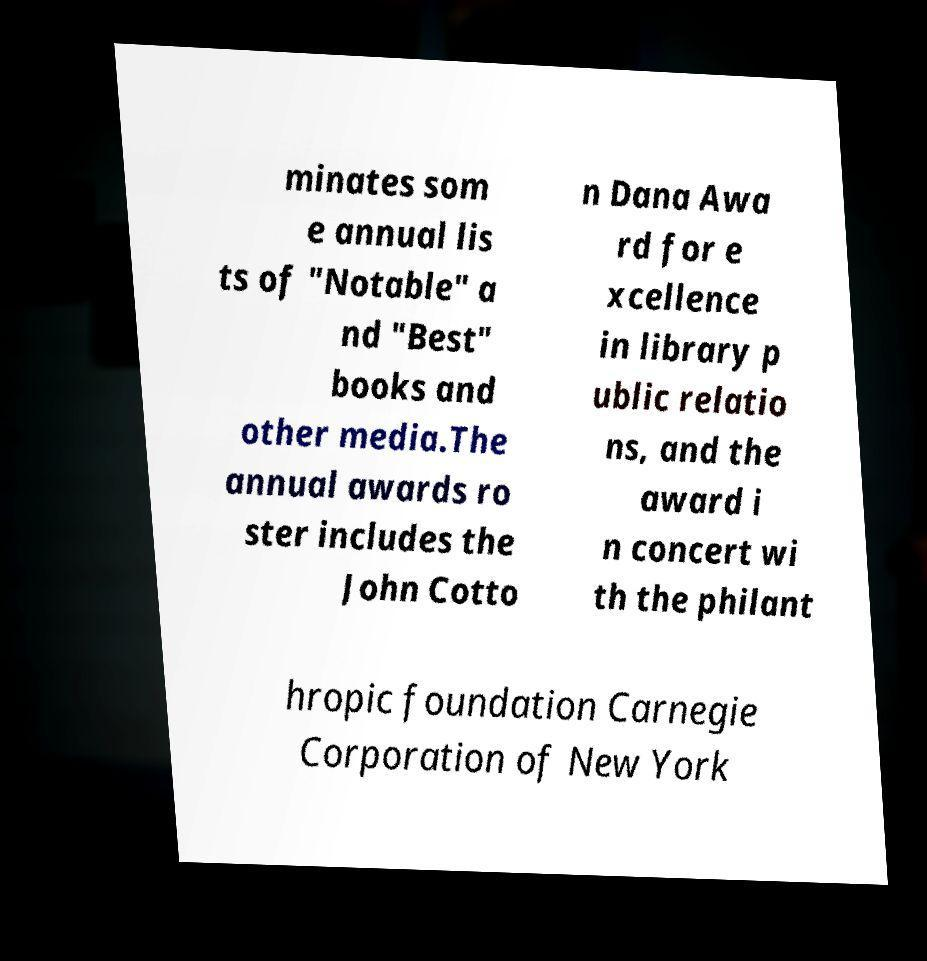Please identify and transcribe the text found in this image. minates som e annual lis ts of "Notable" a nd "Best" books and other media.The annual awards ro ster includes the John Cotto n Dana Awa rd for e xcellence in library p ublic relatio ns, and the award i n concert wi th the philant hropic foundation Carnegie Corporation of New York 